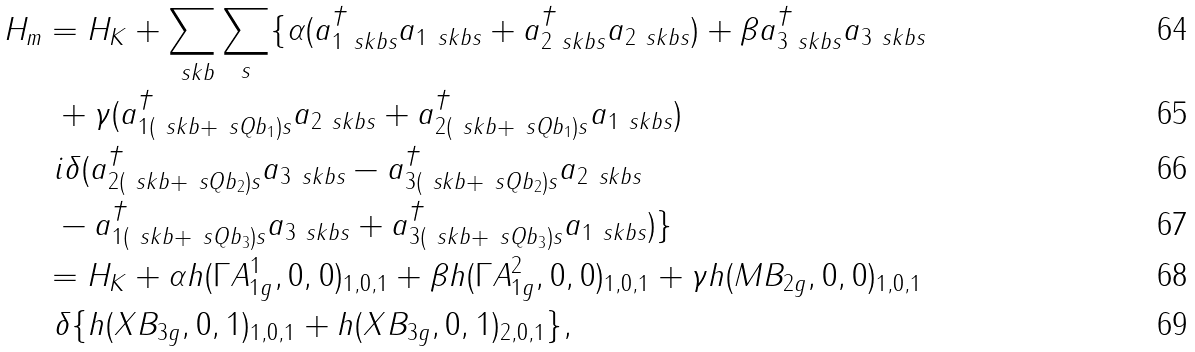Convert formula to latex. <formula><loc_0><loc_0><loc_500><loc_500>H _ { m } & = H _ { K } + \sum _ { \ s k b } \sum _ { s } \{ \alpha ( a ^ { \dag } _ { 1 \ s k b s } a _ { 1 \ s k b s } + a ^ { \dag } _ { 2 \ s k b s } a _ { 2 \ s k b s } ) + \beta a ^ { \dag } _ { 3 \ s k b s } a _ { 3 \ s k b s } \\ & \ + \gamma ( a ^ { \dag } _ { 1 ( \ s k b + \ s Q b _ { 1 } ) s } a _ { 2 \ s k b s } + a ^ { \dag } _ { 2 ( \ s k b + \ s Q b _ { 1 } ) s } a _ { 1 \ s k b s } ) \\ & \ i \delta ( a ^ { \dag } _ { 2 ( \ s k b + \ s Q b _ { 2 } ) s } a _ { 3 \ s k b s } - a ^ { \dag } _ { 3 ( \ s k b + \ s Q b _ { 2 } ) s } a _ { 2 \ s k b s } \\ & \ - a ^ { \dag } _ { 1 ( \ s k b + \ s Q b _ { 3 } ) s } a _ { 3 \ s k b s } + a ^ { \dag } _ { 3 ( \ s k b + \ s Q b _ { 3 } ) s } a _ { 1 \ s k b s } ) \} \\ & = H _ { K } + \alpha h ( \Gamma A ^ { 1 } _ { 1 g } , 0 , 0 ) _ { 1 , 0 , 1 } + \beta h ( \Gamma A ^ { 2 } _ { 1 g } , 0 , 0 ) _ { 1 , 0 , 1 } + \gamma h ( M B _ { 2 g } , 0 , 0 ) _ { 1 , 0 , 1 } \\ & \ \delta \{ h ( X B _ { 3 g } , 0 , 1 ) _ { 1 , 0 , 1 } + h ( X B _ { 3 g } , 0 , 1 ) _ { 2 , 0 , 1 } \} ,</formula> 